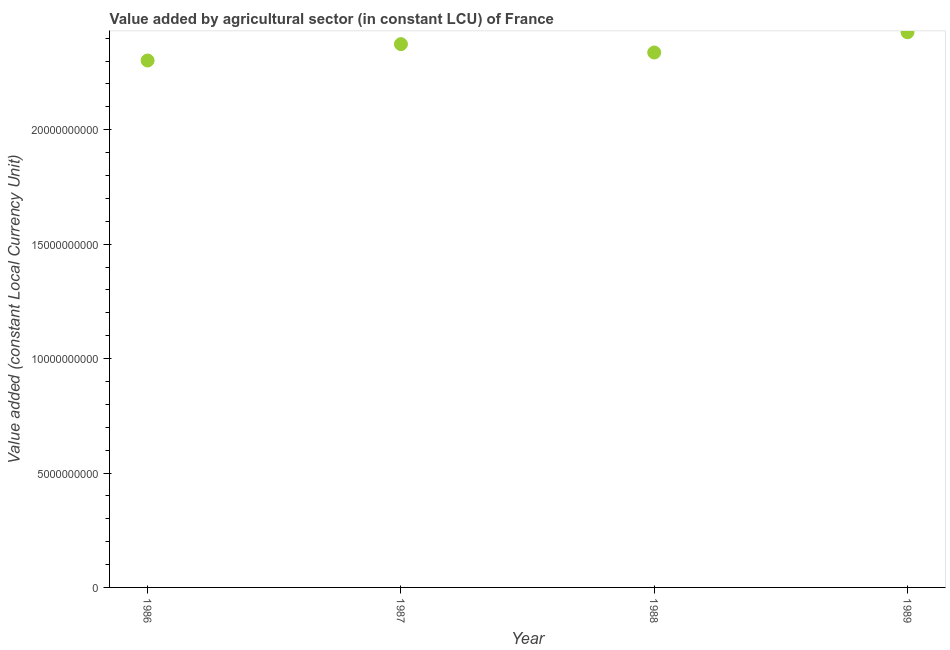What is the value added by agriculture sector in 1988?
Ensure brevity in your answer.  2.34e+1. Across all years, what is the maximum value added by agriculture sector?
Keep it short and to the point. 2.43e+1. Across all years, what is the minimum value added by agriculture sector?
Offer a terse response. 2.30e+1. In which year was the value added by agriculture sector maximum?
Keep it short and to the point. 1989. What is the sum of the value added by agriculture sector?
Your answer should be compact. 9.44e+1. What is the difference between the value added by agriculture sector in 1986 and 1987?
Your response must be concise. -7.16e+08. What is the average value added by agriculture sector per year?
Your answer should be compact. 2.36e+1. What is the median value added by agriculture sector?
Your answer should be very brief. 2.36e+1. In how many years, is the value added by agriculture sector greater than 17000000000 LCU?
Provide a short and direct response. 4. What is the ratio of the value added by agriculture sector in 1986 to that in 1987?
Make the answer very short. 0.97. Is the difference between the value added by agriculture sector in 1987 and 1989 greater than the difference between any two years?
Make the answer very short. No. What is the difference between the highest and the second highest value added by agriculture sector?
Ensure brevity in your answer.  5.20e+08. What is the difference between the highest and the lowest value added by agriculture sector?
Give a very brief answer. 1.24e+09. Does the value added by agriculture sector monotonically increase over the years?
Your answer should be compact. No. Does the graph contain any zero values?
Offer a terse response. No. What is the title of the graph?
Provide a succinct answer. Value added by agricultural sector (in constant LCU) of France. What is the label or title of the Y-axis?
Provide a succinct answer. Value added (constant Local Currency Unit). What is the Value added (constant Local Currency Unit) in 1986?
Your answer should be very brief. 2.30e+1. What is the Value added (constant Local Currency Unit) in 1987?
Keep it short and to the point. 2.37e+1. What is the Value added (constant Local Currency Unit) in 1988?
Provide a succinct answer. 2.34e+1. What is the Value added (constant Local Currency Unit) in 1989?
Make the answer very short. 2.43e+1. What is the difference between the Value added (constant Local Currency Unit) in 1986 and 1987?
Your answer should be very brief. -7.16e+08. What is the difference between the Value added (constant Local Currency Unit) in 1986 and 1988?
Your answer should be very brief. -3.50e+08. What is the difference between the Value added (constant Local Currency Unit) in 1986 and 1989?
Give a very brief answer. -1.24e+09. What is the difference between the Value added (constant Local Currency Unit) in 1987 and 1988?
Provide a succinct answer. 3.66e+08. What is the difference between the Value added (constant Local Currency Unit) in 1987 and 1989?
Your answer should be very brief. -5.20e+08. What is the difference between the Value added (constant Local Currency Unit) in 1988 and 1989?
Your answer should be compact. -8.86e+08. What is the ratio of the Value added (constant Local Currency Unit) in 1986 to that in 1988?
Provide a short and direct response. 0.98. What is the ratio of the Value added (constant Local Currency Unit) in 1986 to that in 1989?
Keep it short and to the point. 0.95. What is the ratio of the Value added (constant Local Currency Unit) in 1987 to that in 1988?
Your answer should be compact. 1.02. What is the ratio of the Value added (constant Local Currency Unit) in 1987 to that in 1989?
Provide a short and direct response. 0.98. 